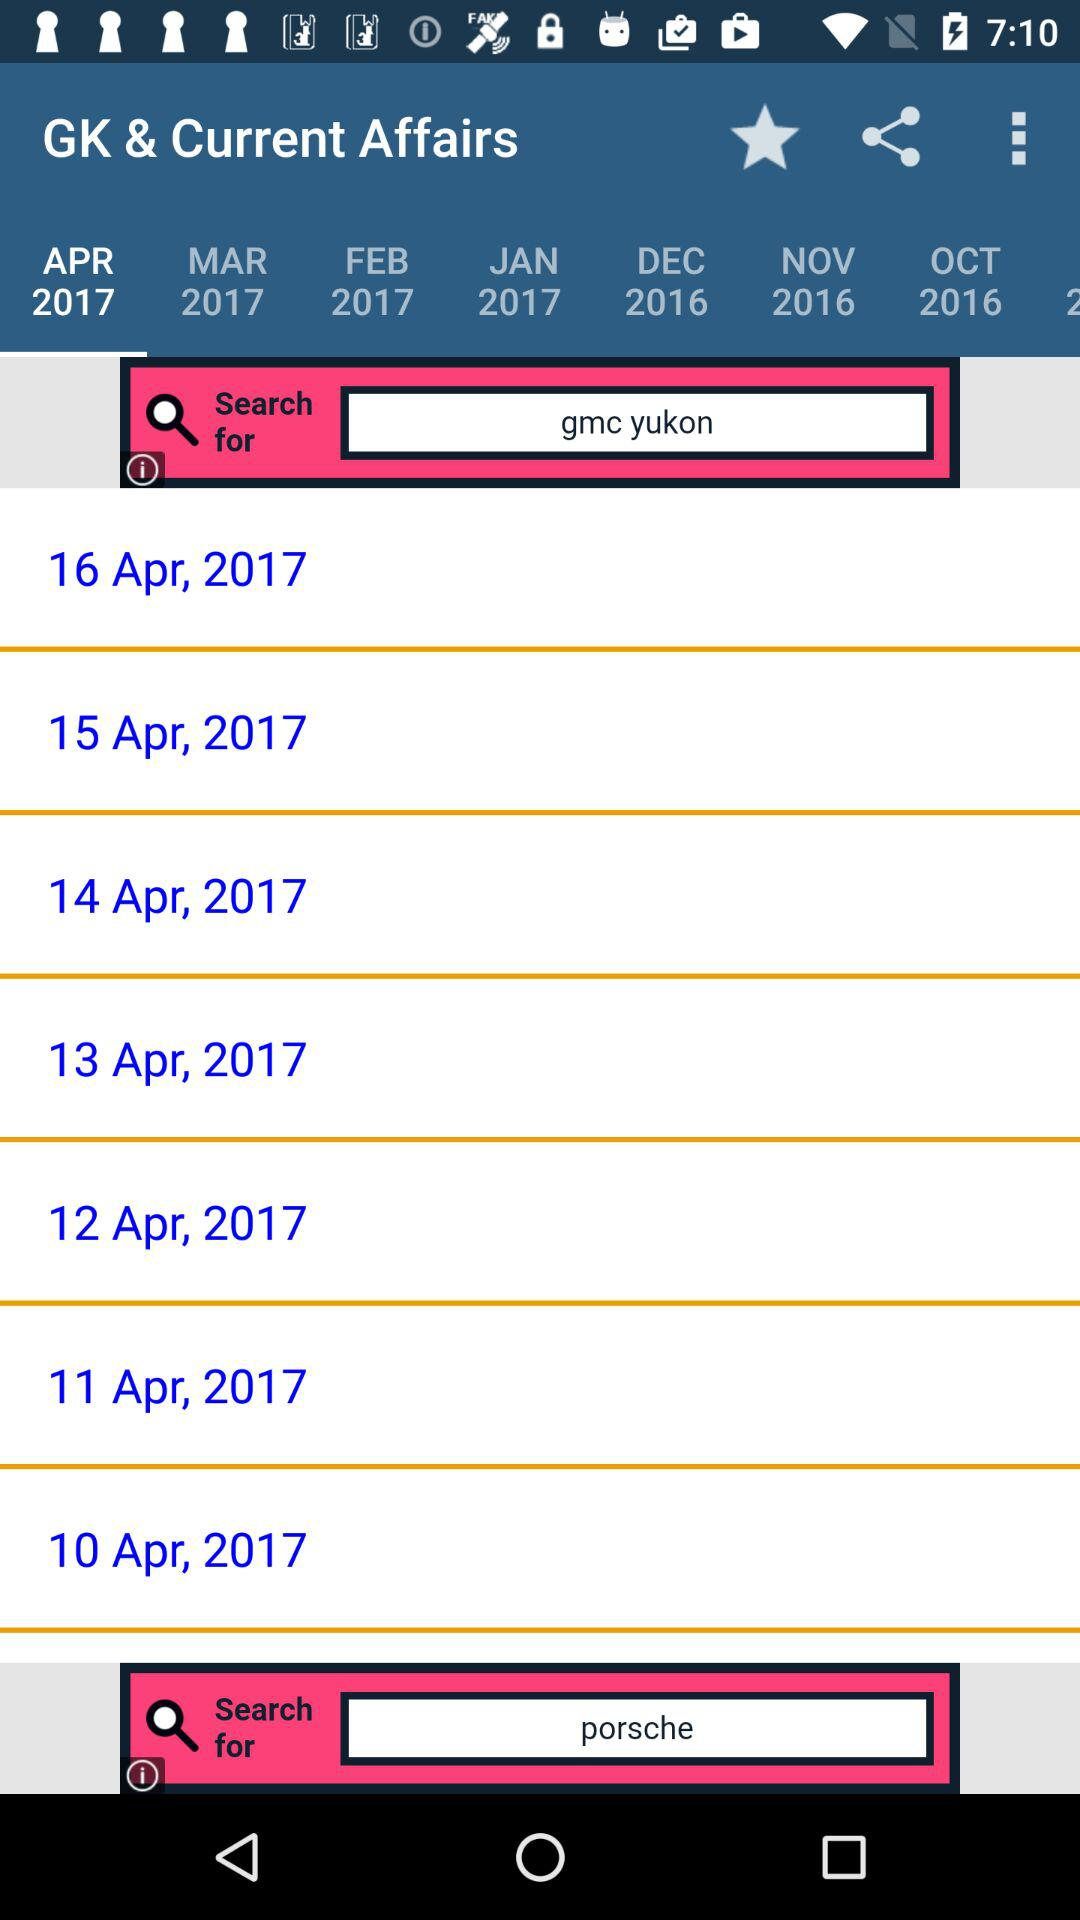Which tab is selected? The selected tab is "APR 2017". 